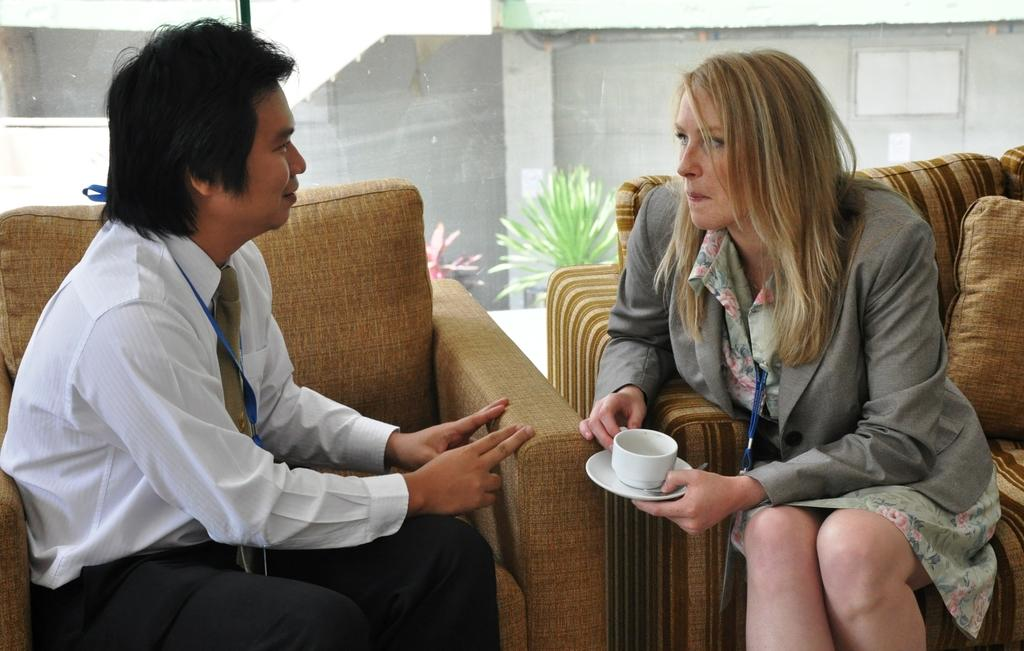Who is present in the image? There is a man and a woman in the image. What are the man and woman doing in the image? The man and woman are sitting on a sofa. What is the woman holding in the image? The woman is holding a cup and saucer. What can be seen in the background of the image? There are plants in the background of the image. What type of prose is being recited by the man in the image? There is no indication in the image that the man is reciting any prose. 